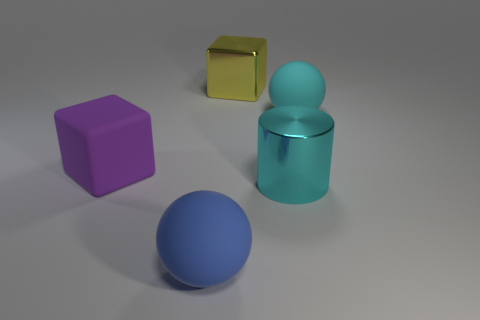Subtract all blue spheres. How many spheres are left? 1 Subtract 1 cylinders. How many cylinders are left? 0 Add 3 small yellow cylinders. How many objects exist? 8 Subtract all cylinders. How many objects are left? 4 Subtract all big cyan metallic cylinders. Subtract all big blocks. How many objects are left? 2 Add 2 big metal cylinders. How many big metal cylinders are left? 3 Add 1 big metal cylinders. How many big metal cylinders exist? 2 Subtract 0 blue cylinders. How many objects are left? 5 Subtract all green spheres. Subtract all brown cubes. How many spheres are left? 2 